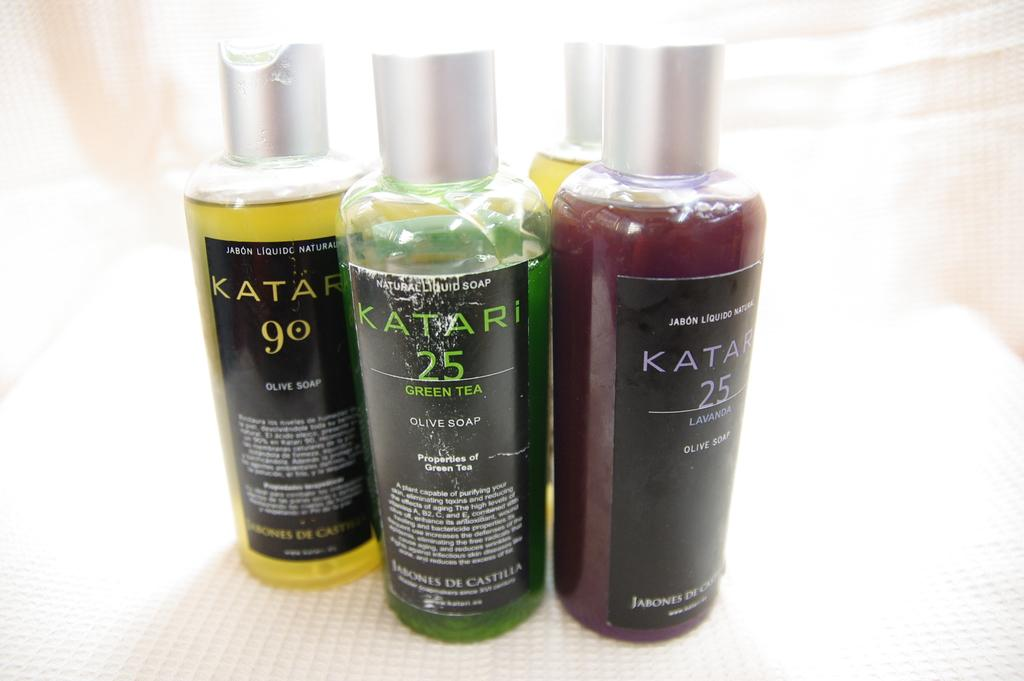<image>
Describe the image concisely. Different varieties plastic bottles with olive soap written on them. 